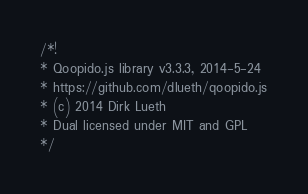<code> <loc_0><loc_0><loc_500><loc_500><_JavaScript_>/*!
* Qoopido.js library v3.3.3, 2014-5-24
* https://github.com/dlueth/qoopido.js
* (c) 2014 Dirk Lueth
* Dual licensed under MIT and GPL
*/</code> 